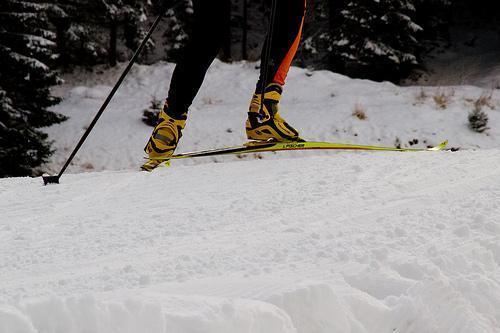How many people are in the picture?
Give a very brief answer. 1. 